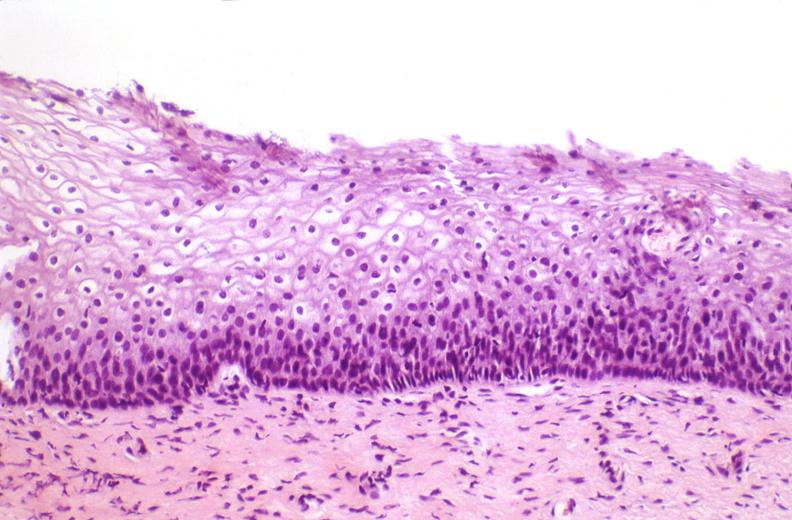what does this image show?
Answer the question using a single word or phrase. Cervix 